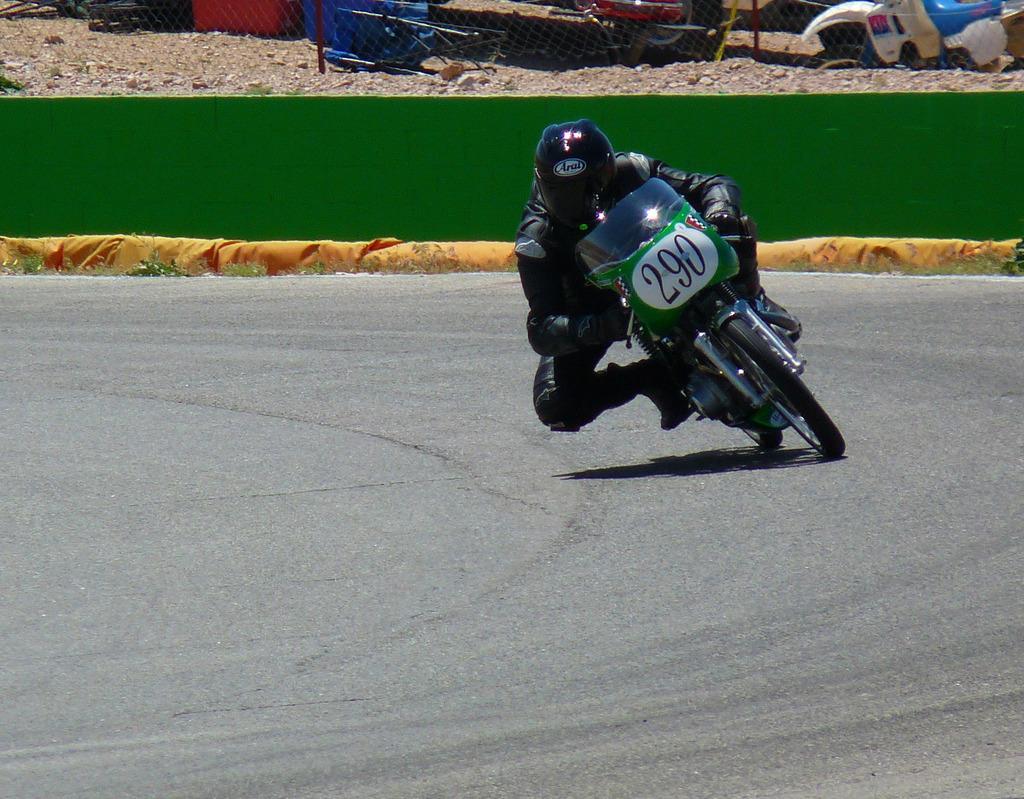Describe this image in one or two sentences. In this image there is a person riding a vehicle and there are some numbers written on the vehicle. In the background there is a wall which is green in colour and there is a fence, behind the fence there are objects which are red, blue and white in colour and in front of the wall there is an object which is yellow in colour. 